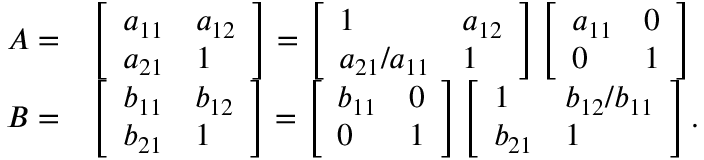<formula> <loc_0><loc_0><loc_500><loc_500>\begin{array} { r l } { A = } & { \left [ \begin{array} { l l } { a _ { 1 1 } } & { a _ { 1 2 } } \\ { a _ { 2 1 } } & { 1 } \end{array} \right ] = \left [ \begin{array} { l l } { 1 } & { a _ { 1 2 } } \\ { a _ { 2 1 } / a _ { 1 1 } } & { 1 } \end{array} \right ] \left [ \begin{array} { l l } { a _ { 1 1 } } & { 0 } \\ { 0 } & { 1 } \end{array} \right ] } \\ { B = } & { \left [ \begin{array} { l l } { b _ { 1 1 } } & { b _ { 1 2 } } \\ { b _ { 2 1 } } & { 1 } \end{array} \right ] = \left [ \begin{array} { l l } { b _ { 1 1 } } & { 0 } \\ { 0 } & { 1 } \end{array} \right ] \left [ \begin{array} { l l } { 1 } & { b _ { 1 2 } / b _ { 1 1 } } \\ { b _ { 2 1 } } & { 1 } \end{array} \right ] . } \end{array}</formula> 